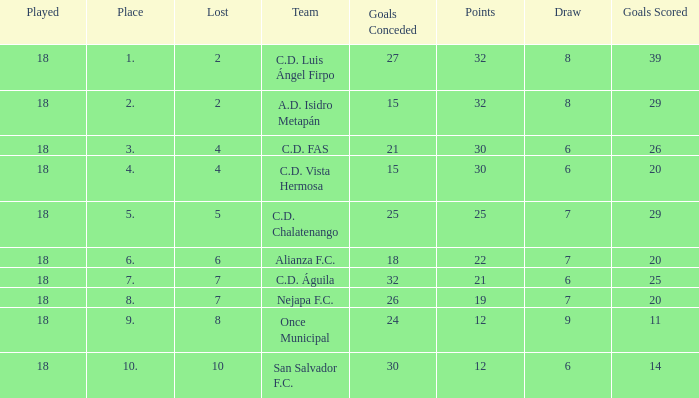What team with a goals conceded smaller than 25, and a place smaller than 3? A.D. Isidro Metapán. 